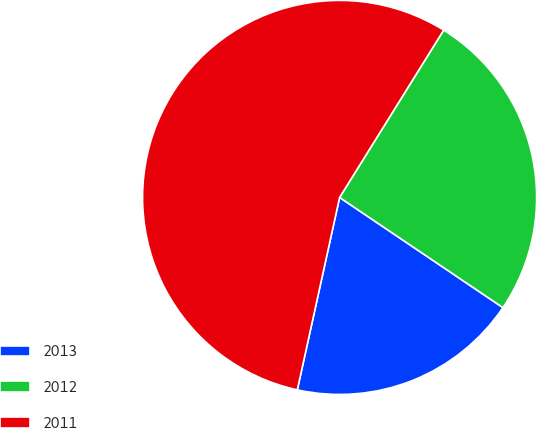Convert chart. <chart><loc_0><loc_0><loc_500><loc_500><pie_chart><fcel>2013<fcel>2012<fcel>2011<nl><fcel>19.0%<fcel>25.59%<fcel>55.41%<nl></chart> 